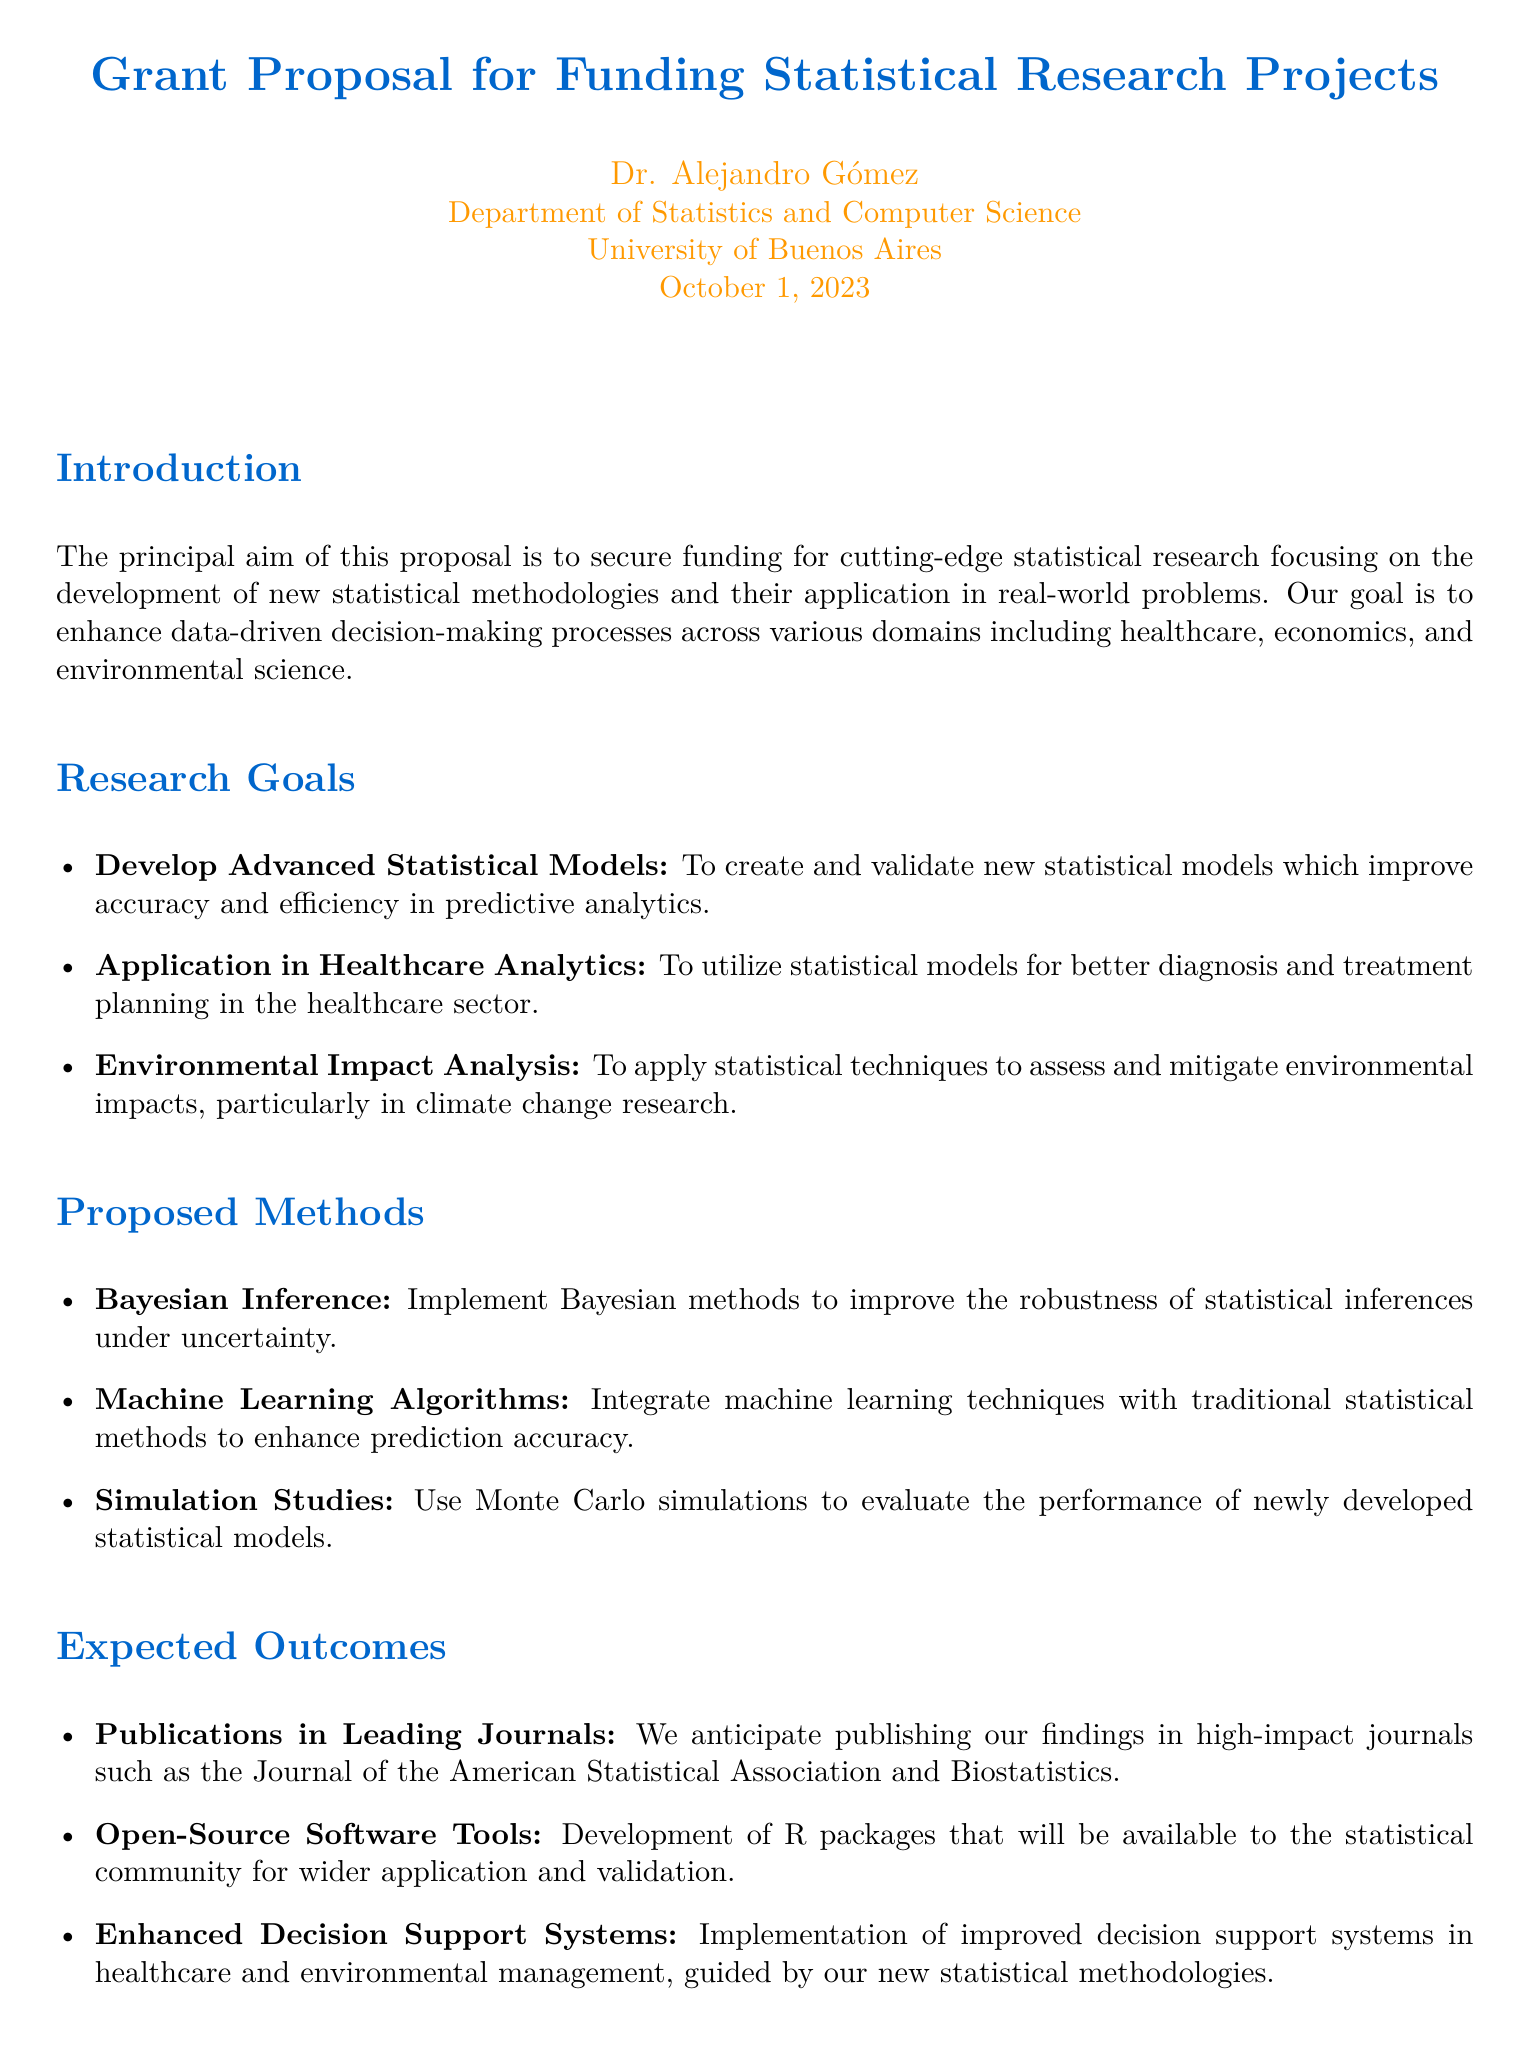What is the purpose of the proposal? The proposal aims to secure funding for cutting-edge statistical research focusing on the development of new statistical methodologies and their application in real-world problems.
Answer: funding for statistical research Who is the principal investigator? The principal investigator of the grant proposal is Dr. Alejandro Gómez.
Answer: Dr. Alejandro Gómez What is one of the research goals? One of the research goals includes the application of statistical models in healthcare analytics.
Answer: application in healthcare analytics What methodology is proposed for evaluation? The document mentions the use of Monte Carlo simulations to evaluate the performance of newly developed statistical models.
Answer: Monte Carlo simulations Which journals are anticipated for publication? The anticipated journals include the Journal of the American Statistical Association and Biostatistics.
Answer: Journal of the American Statistical Association and Biostatistics What statistical methods will be integrated with traditional methods? The proposal indicates that machine learning algorithms will be integrated with traditional statistical methods.
Answer: machine learning algorithms What type of software tools are expected to be developed? The expected software tools are R packages that will be available to the statistical community.
Answer: R packages When was the document created? The document was created on October 1, 2023.
Answer: October 1, 2023 